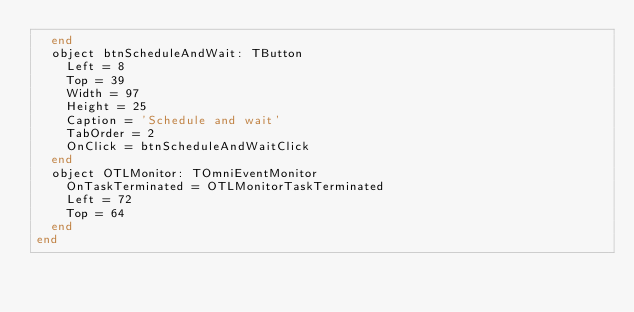Convert code to text. <code><loc_0><loc_0><loc_500><loc_500><_Pascal_>  end
  object btnScheduleAndWait: TButton
    Left = 8
    Top = 39
    Width = 97
    Height = 25
    Caption = 'Schedule and wait'
    TabOrder = 2
    OnClick = btnScheduleAndWaitClick
  end
  object OTLMonitor: TOmniEventMonitor
    OnTaskTerminated = OTLMonitorTaskTerminated
    Left = 72
    Top = 64
  end
end
</code> 